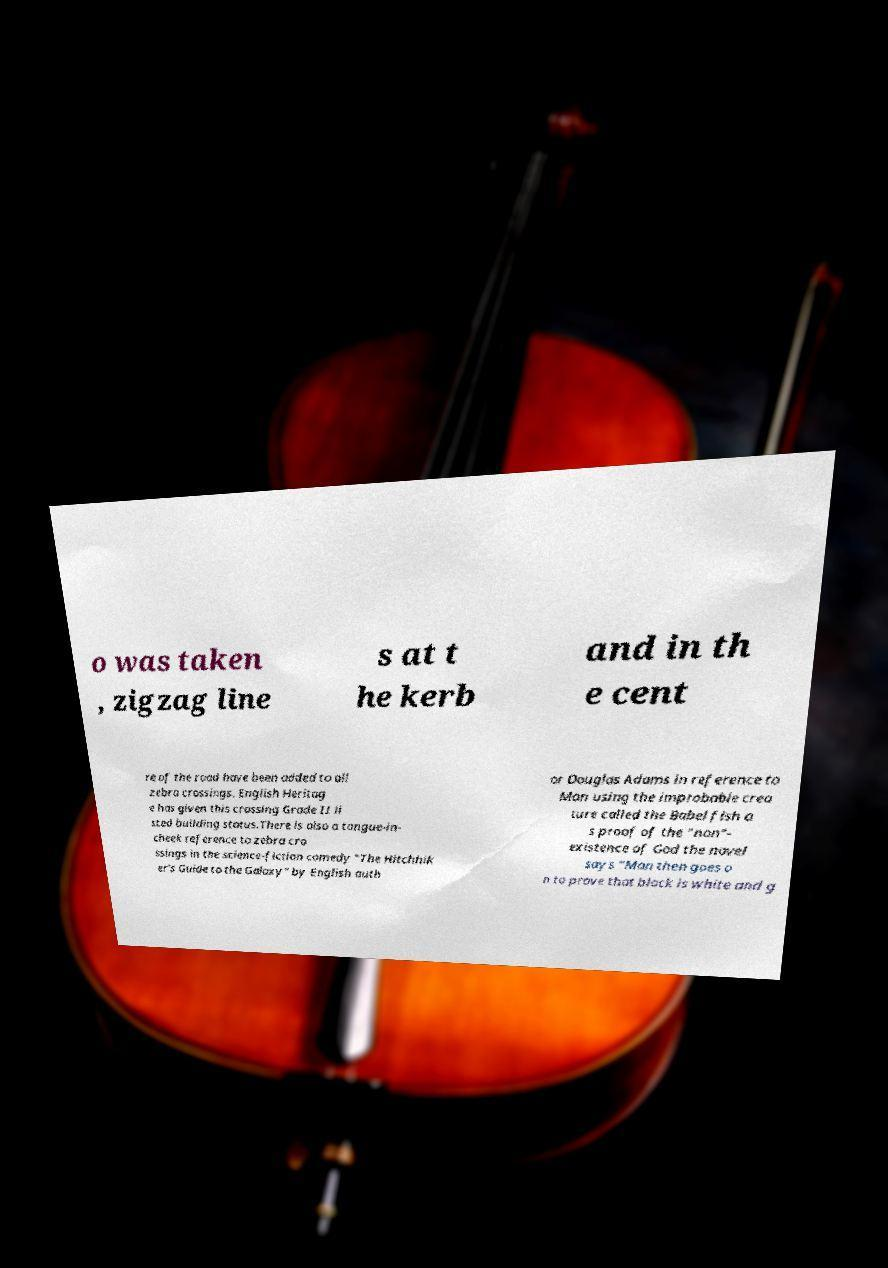For documentation purposes, I need the text within this image transcribed. Could you provide that? o was taken , zigzag line s at t he kerb and in th e cent re of the road have been added to all zebra crossings. English Heritag e has given this crossing Grade II li sted building status.There is also a tongue-in- cheek reference to zebra cro ssings in the science-fiction comedy "The Hitchhik er's Guide to the Galaxy" by English auth or Douglas Adams in reference to Man using the improbable crea ture called the Babel fish a s proof of the "non"- existence of God the novel says "Man then goes o n to prove that black is white and g 